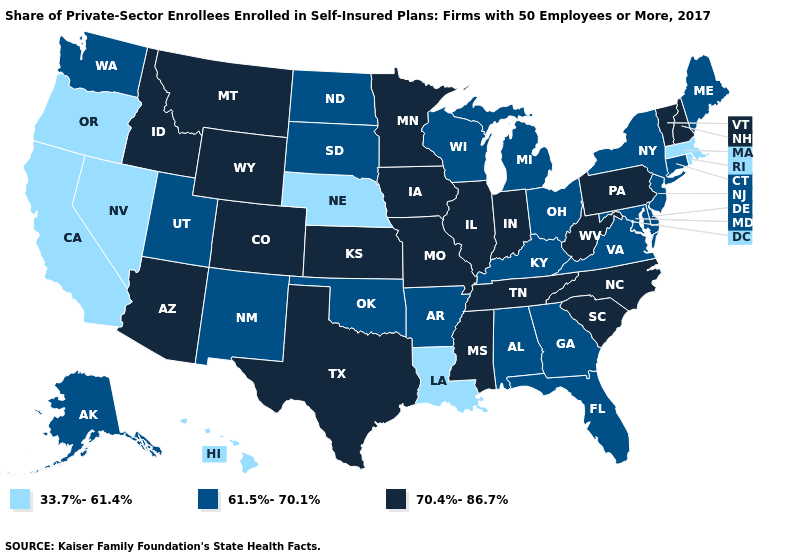Which states hav the highest value in the Northeast?
Give a very brief answer. New Hampshire, Pennsylvania, Vermont. Which states hav the highest value in the Northeast?
Answer briefly. New Hampshire, Pennsylvania, Vermont. Name the states that have a value in the range 33.7%-61.4%?
Write a very short answer. California, Hawaii, Louisiana, Massachusetts, Nebraska, Nevada, Oregon, Rhode Island. What is the highest value in states that border Arizona?
Be succinct. 70.4%-86.7%. What is the value of Colorado?
Write a very short answer. 70.4%-86.7%. Does the map have missing data?
Write a very short answer. No. What is the value of Virginia?
Quick response, please. 61.5%-70.1%. What is the highest value in states that border Indiana?
Answer briefly. 70.4%-86.7%. Does Illinois have the highest value in the USA?
Write a very short answer. Yes. Does Utah have the lowest value in the West?
Quick response, please. No. Name the states that have a value in the range 61.5%-70.1%?
Answer briefly. Alabama, Alaska, Arkansas, Connecticut, Delaware, Florida, Georgia, Kentucky, Maine, Maryland, Michigan, New Jersey, New Mexico, New York, North Dakota, Ohio, Oklahoma, South Dakota, Utah, Virginia, Washington, Wisconsin. What is the highest value in the MidWest ?
Concise answer only. 70.4%-86.7%. Among the states that border Mississippi , does Louisiana have the lowest value?
Answer briefly. Yes. Among the states that border Georgia , does Alabama have the highest value?
Write a very short answer. No. 